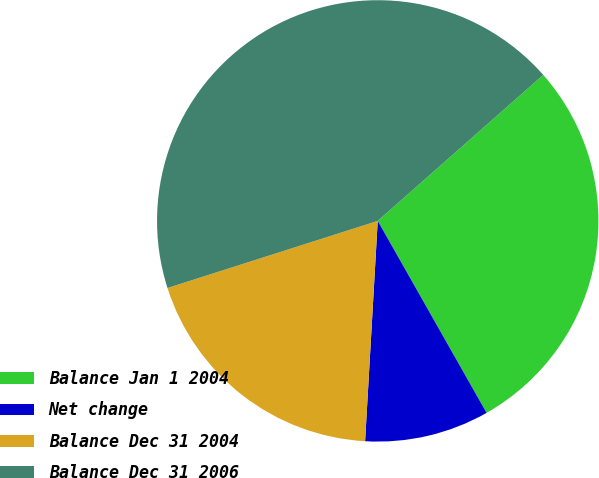Convert chart. <chart><loc_0><loc_0><loc_500><loc_500><pie_chart><fcel>Balance Jan 1 2004<fcel>Net change<fcel>Balance Dec 31 2004<fcel>Balance Dec 31 2006<nl><fcel>28.29%<fcel>9.12%<fcel>19.17%<fcel>43.41%<nl></chart> 